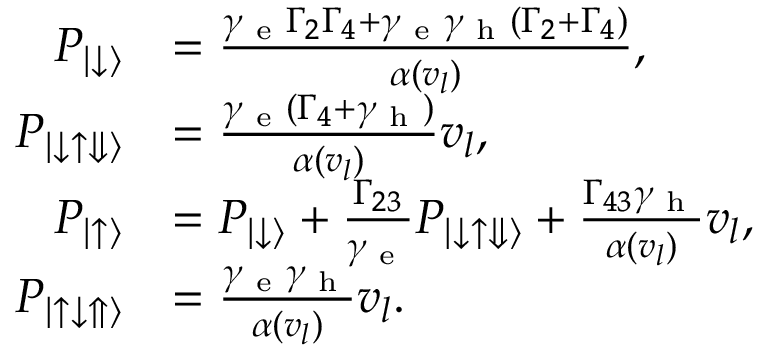Convert formula to latex. <formula><loc_0><loc_0><loc_500><loc_500>\begin{array} { r l } { P _ { | \downarrow \rangle } } & { = \frac { \gamma _ { e } \Gamma _ { 2 } \Gamma _ { 4 } + \gamma _ { e } \gamma _ { h } ( \Gamma _ { 2 } + \Gamma _ { 4 } ) } { \alpha ( v _ { l } ) } , } \\ { P _ { | \downarrow \uparrow \Downarrow \rangle } } & { = \frac { \gamma _ { e } ( \Gamma _ { 4 } + \gamma _ { h } ) } { \alpha ( v _ { l } ) } v _ { l } , } \\ { P _ { \left | \uparrow \right \rangle } } & { = P _ { | \downarrow \rangle } + \frac { \Gamma _ { 2 3 } } { \gamma _ { e } } P _ { | \downarrow \uparrow \Downarrow \rangle } + \frac { \Gamma _ { 4 3 } \gamma _ { h } } { \alpha ( v _ { l } ) } v _ { l } , } \\ { P _ { | \uparrow \downarrow \Uparrow \rangle } } & { = \frac { \gamma _ { e } \gamma _ { h } } { \alpha ( v _ { l } ) } v _ { l } . } \end{array}</formula> 